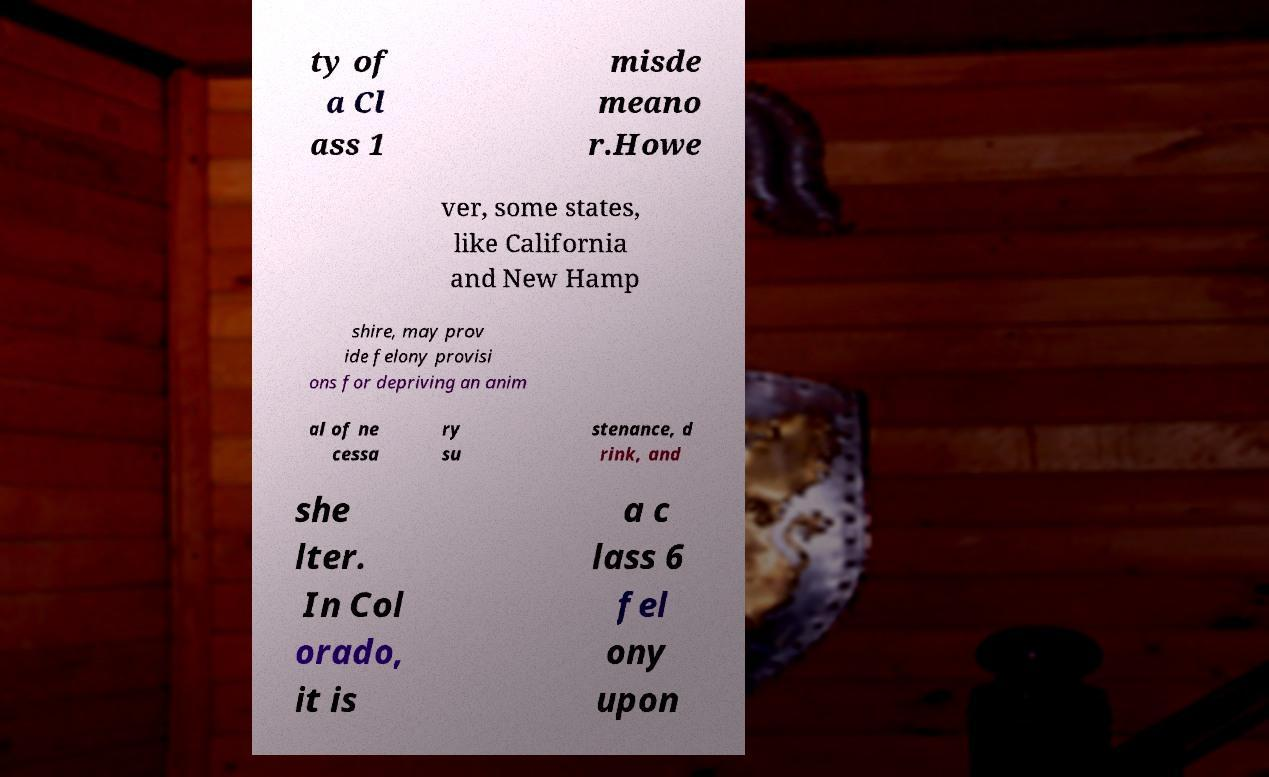For documentation purposes, I need the text within this image transcribed. Could you provide that? ty of a Cl ass 1 misde meano r.Howe ver, some states, like California and New Hamp shire, may prov ide felony provisi ons for depriving an anim al of ne cessa ry su stenance, d rink, and she lter. In Col orado, it is a c lass 6 fel ony upon 